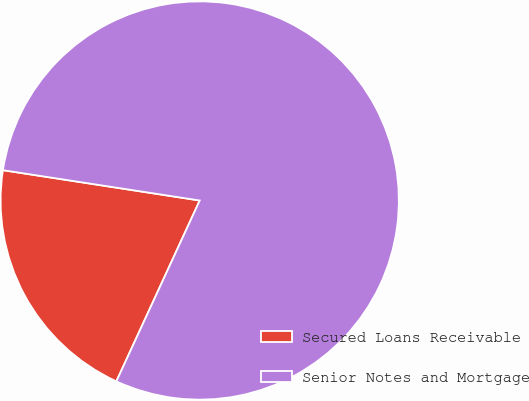Convert chart. <chart><loc_0><loc_0><loc_500><loc_500><pie_chart><fcel>Secured Loans Receivable<fcel>Senior Notes and Mortgage<nl><fcel>20.56%<fcel>79.44%<nl></chart> 